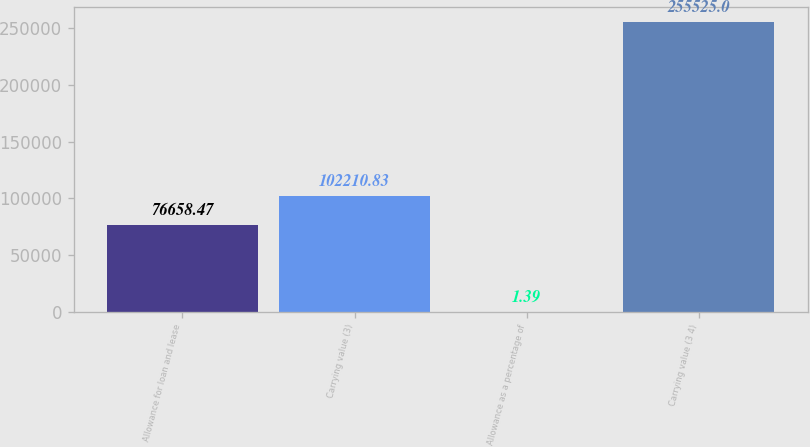Convert chart to OTSL. <chart><loc_0><loc_0><loc_500><loc_500><bar_chart><fcel>Allowance for loan and lease<fcel>Carrying value (3)<fcel>Allowance as a percentage of<fcel>Carrying value (3 4)<nl><fcel>76658.5<fcel>102211<fcel>1.39<fcel>255525<nl></chart> 